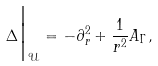Convert formula to latex. <formula><loc_0><loc_0><loc_500><loc_500>\Delta \Big | _ { \mathcal { U } } = - \partial _ { r } ^ { 2 } + \frac { 1 } { r ^ { 2 } } A _ { \Gamma } ,</formula> 